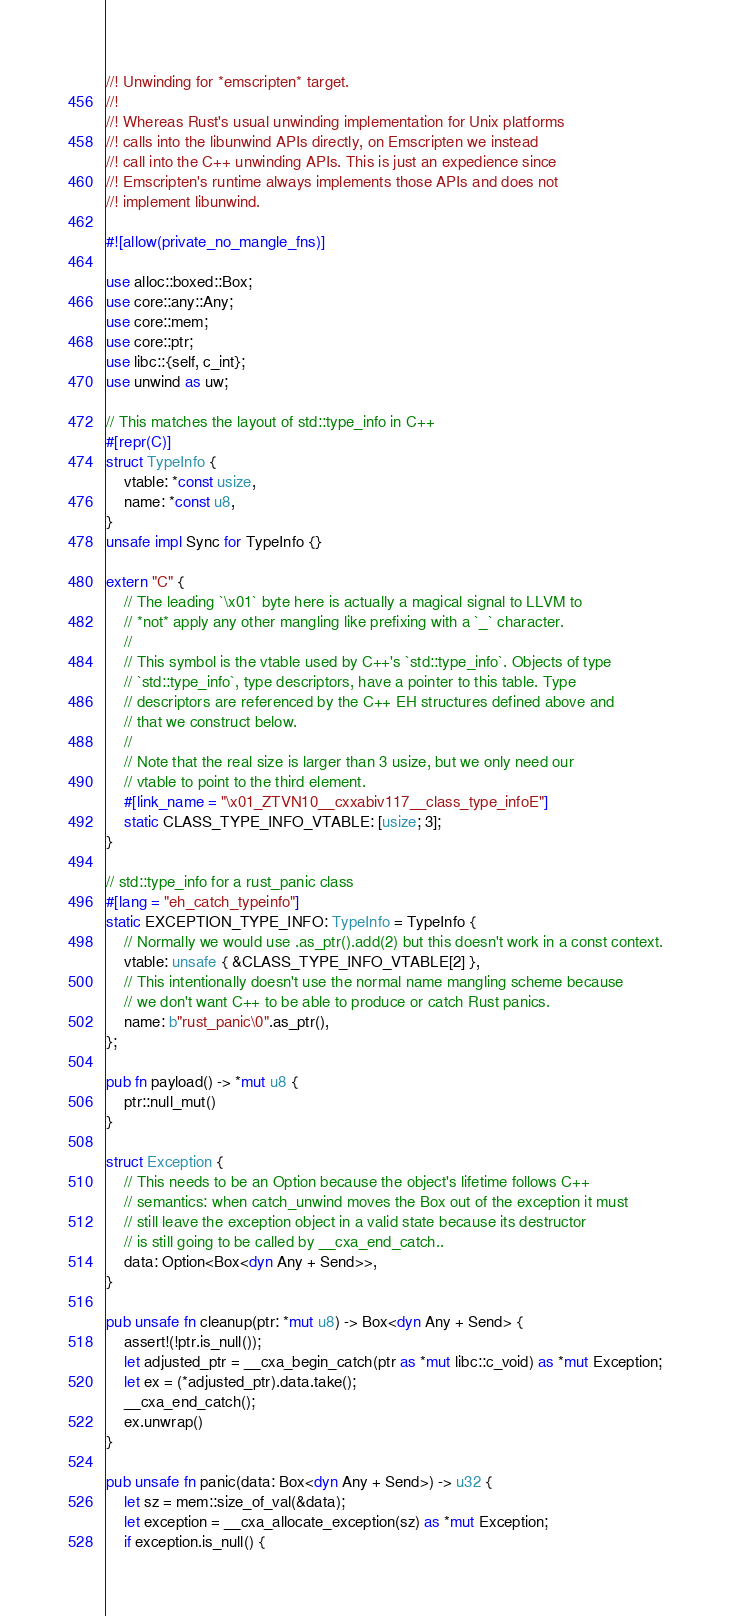<code> <loc_0><loc_0><loc_500><loc_500><_Rust_>//! Unwinding for *emscripten* target.
//!
//! Whereas Rust's usual unwinding implementation for Unix platforms
//! calls into the libunwind APIs directly, on Emscripten we instead
//! call into the C++ unwinding APIs. This is just an expedience since
//! Emscripten's runtime always implements those APIs and does not
//! implement libunwind.

#![allow(private_no_mangle_fns)]

use alloc::boxed::Box;
use core::any::Any;
use core::mem;
use core::ptr;
use libc::{self, c_int};
use unwind as uw;

// This matches the layout of std::type_info in C++
#[repr(C)]
struct TypeInfo {
    vtable: *const usize,
    name: *const u8,
}
unsafe impl Sync for TypeInfo {}

extern "C" {
    // The leading `\x01` byte here is actually a magical signal to LLVM to
    // *not* apply any other mangling like prefixing with a `_` character.
    //
    // This symbol is the vtable used by C++'s `std::type_info`. Objects of type
    // `std::type_info`, type descriptors, have a pointer to this table. Type
    // descriptors are referenced by the C++ EH structures defined above and
    // that we construct below.
    //
    // Note that the real size is larger than 3 usize, but we only need our
    // vtable to point to the third element.
    #[link_name = "\x01_ZTVN10__cxxabiv117__class_type_infoE"]
    static CLASS_TYPE_INFO_VTABLE: [usize; 3];
}

// std::type_info for a rust_panic class
#[lang = "eh_catch_typeinfo"]
static EXCEPTION_TYPE_INFO: TypeInfo = TypeInfo {
    // Normally we would use .as_ptr().add(2) but this doesn't work in a const context.
    vtable: unsafe { &CLASS_TYPE_INFO_VTABLE[2] },
    // This intentionally doesn't use the normal name mangling scheme because
    // we don't want C++ to be able to produce or catch Rust panics.
    name: b"rust_panic\0".as_ptr(),
};

pub fn payload() -> *mut u8 {
    ptr::null_mut()
}

struct Exception {
    // This needs to be an Option because the object's lifetime follows C++
    // semantics: when catch_unwind moves the Box out of the exception it must
    // still leave the exception object in a valid state because its destructor
    // is still going to be called by __cxa_end_catch..
    data: Option<Box<dyn Any + Send>>,
}

pub unsafe fn cleanup(ptr: *mut u8) -> Box<dyn Any + Send> {
    assert!(!ptr.is_null());
    let adjusted_ptr = __cxa_begin_catch(ptr as *mut libc::c_void) as *mut Exception;
    let ex = (*adjusted_ptr).data.take();
    __cxa_end_catch();
    ex.unwrap()
}

pub unsafe fn panic(data: Box<dyn Any + Send>) -> u32 {
    let sz = mem::size_of_val(&data);
    let exception = __cxa_allocate_exception(sz) as *mut Exception;
    if exception.is_null() {</code> 